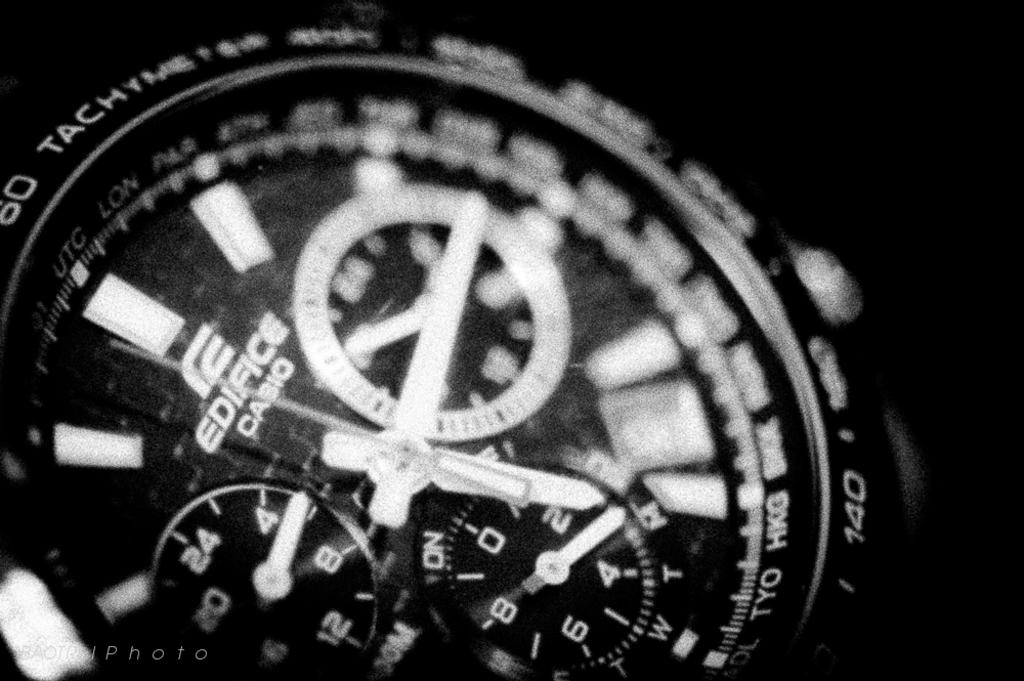What is the main subject of the image? The main subject of the image is a watch dial. What is the color scheme of the image? The image is black and white. Is there any coal visible in the image? No, there is no coal present in the image. Can you see any quicksand in the image? No, there is no quicksand present in the image. 